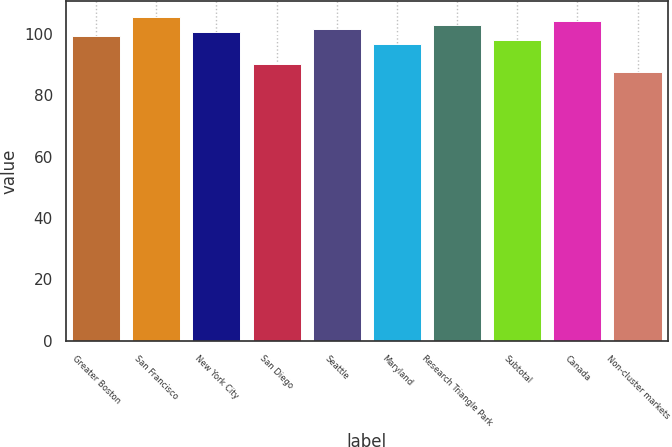Convert chart. <chart><loc_0><loc_0><loc_500><loc_500><bar_chart><fcel>Greater Boston<fcel>San Francisco<fcel>New York City<fcel>San Diego<fcel>Seattle<fcel>Maryland<fcel>Research Triangle Park<fcel>Subtotal<fcel>Canada<fcel>Non-cluster markets<nl><fcel>99.36<fcel>105.46<fcel>100.58<fcel>90.4<fcel>101.8<fcel>96.92<fcel>103.02<fcel>98.14<fcel>104.24<fcel>87.7<nl></chart> 